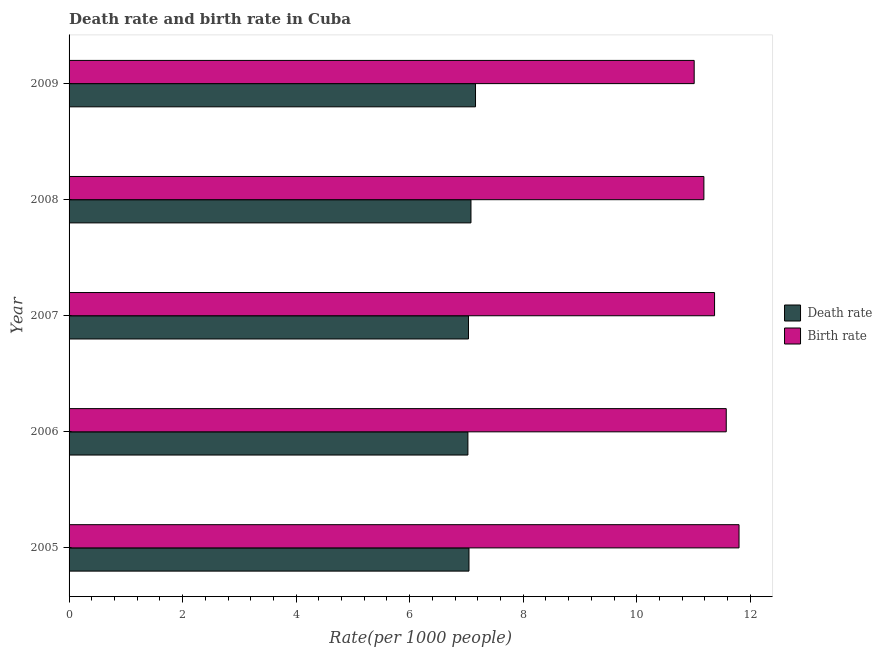How many bars are there on the 4th tick from the top?
Give a very brief answer. 2. How many bars are there on the 1st tick from the bottom?
Your response must be concise. 2. What is the label of the 3rd group of bars from the top?
Give a very brief answer. 2007. What is the birth rate in 2007?
Offer a terse response. 11.37. Across all years, what is the maximum death rate?
Your response must be concise. 7.16. Across all years, what is the minimum birth rate?
Provide a succinct answer. 11.01. What is the total birth rate in the graph?
Ensure brevity in your answer.  56.95. What is the difference between the death rate in 2005 and that in 2007?
Offer a terse response. 0.01. What is the difference between the death rate in 2006 and the birth rate in 2007?
Your answer should be very brief. -4.35. What is the average death rate per year?
Your answer should be compact. 7.07. In the year 2005, what is the difference between the death rate and birth rate?
Provide a succinct answer. -4.76. In how many years, is the death rate greater than 5.2 ?
Keep it short and to the point. 5. What is the ratio of the death rate in 2005 to that in 2008?
Your response must be concise. 0.99. Is the death rate in 2007 less than that in 2008?
Offer a terse response. Yes. Is the difference between the birth rate in 2007 and 2008 greater than the difference between the death rate in 2007 and 2008?
Your response must be concise. Yes. What is the difference between the highest and the second highest birth rate?
Offer a terse response. 0.23. What is the difference between the highest and the lowest birth rate?
Keep it short and to the point. 0.79. In how many years, is the death rate greater than the average death rate taken over all years?
Offer a terse response. 2. What does the 2nd bar from the top in 2009 represents?
Provide a succinct answer. Death rate. What does the 2nd bar from the bottom in 2009 represents?
Your answer should be very brief. Birth rate. How many bars are there?
Your answer should be compact. 10. Are all the bars in the graph horizontal?
Offer a terse response. Yes. What is the difference between two consecutive major ticks on the X-axis?
Offer a very short reply. 2. Are the values on the major ticks of X-axis written in scientific E-notation?
Give a very brief answer. No. How are the legend labels stacked?
Provide a succinct answer. Vertical. What is the title of the graph?
Give a very brief answer. Death rate and birth rate in Cuba. Does "Infant" appear as one of the legend labels in the graph?
Offer a terse response. No. What is the label or title of the X-axis?
Give a very brief answer. Rate(per 1000 people). What is the label or title of the Y-axis?
Your answer should be compact. Year. What is the Rate(per 1000 people) of Death rate in 2005?
Provide a succinct answer. 7.04. What is the Rate(per 1000 people) of Birth rate in 2005?
Offer a terse response. 11.8. What is the Rate(per 1000 people) of Death rate in 2006?
Ensure brevity in your answer.  7.03. What is the Rate(per 1000 people) of Birth rate in 2006?
Your answer should be very brief. 11.58. What is the Rate(per 1000 people) of Death rate in 2007?
Ensure brevity in your answer.  7.04. What is the Rate(per 1000 people) of Birth rate in 2007?
Make the answer very short. 11.37. What is the Rate(per 1000 people) in Death rate in 2008?
Make the answer very short. 7.08. What is the Rate(per 1000 people) of Birth rate in 2008?
Offer a terse response. 11.18. What is the Rate(per 1000 people) of Death rate in 2009?
Offer a very short reply. 7.16. What is the Rate(per 1000 people) of Birth rate in 2009?
Make the answer very short. 11.01. Across all years, what is the maximum Rate(per 1000 people) of Death rate?
Your answer should be very brief. 7.16. Across all years, what is the maximum Rate(per 1000 people) in Birth rate?
Your answer should be very brief. 11.8. Across all years, what is the minimum Rate(per 1000 people) in Death rate?
Offer a very short reply. 7.03. Across all years, what is the minimum Rate(per 1000 people) in Birth rate?
Keep it short and to the point. 11.01. What is the total Rate(per 1000 people) in Death rate in the graph?
Make the answer very short. 35.35. What is the total Rate(per 1000 people) of Birth rate in the graph?
Provide a short and direct response. 56.95. What is the difference between the Rate(per 1000 people) in Death rate in 2005 and that in 2006?
Offer a terse response. 0.02. What is the difference between the Rate(per 1000 people) of Birth rate in 2005 and that in 2006?
Make the answer very short. 0.23. What is the difference between the Rate(per 1000 people) of Death rate in 2005 and that in 2007?
Offer a terse response. 0.01. What is the difference between the Rate(per 1000 people) in Birth rate in 2005 and that in 2007?
Your answer should be compact. 0.43. What is the difference between the Rate(per 1000 people) of Death rate in 2005 and that in 2008?
Your answer should be very brief. -0.04. What is the difference between the Rate(per 1000 people) of Birth rate in 2005 and that in 2008?
Your answer should be compact. 0.62. What is the difference between the Rate(per 1000 people) of Death rate in 2005 and that in 2009?
Provide a succinct answer. -0.12. What is the difference between the Rate(per 1000 people) of Birth rate in 2005 and that in 2009?
Provide a succinct answer. 0.79. What is the difference between the Rate(per 1000 people) in Death rate in 2006 and that in 2007?
Your answer should be compact. -0.01. What is the difference between the Rate(per 1000 people) in Birth rate in 2006 and that in 2007?
Your answer should be compact. 0.21. What is the difference between the Rate(per 1000 people) of Death rate in 2006 and that in 2008?
Offer a very short reply. -0.05. What is the difference between the Rate(per 1000 people) in Birth rate in 2006 and that in 2008?
Provide a short and direct response. 0.39. What is the difference between the Rate(per 1000 people) of Death rate in 2006 and that in 2009?
Keep it short and to the point. -0.13. What is the difference between the Rate(per 1000 people) in Birth rate in 2006 and that in 2009?
Offer a terse response. 0.56. What is the difference between the Rate(per 1000 people) of Death rate in 2007 and that in 2008?
Your answer should be very brief. -0.04. What is the difference between the Rate(per 1000 people) in Birth rate in 2007 and that in 2008?
Offer a very short reply. 0.19. What is the difference between the Rate(per 1000 people) of Death rate in 2007 and that in 2009?
Ensure brevity in your answer.  -0.12. What is the difference between the Rate(per 1000 people) of Birth rate in 2007 and that in 2009?
Give a very brief answer. 0.36. What is the difference between the Rate(per 1000 people) of Death rate in 2008 and that in 2009?
Your response must be concise. -0.08. What is the difference between the Rate(per 1000 people) of Birth rate in 2008 and that in 2009?
Offer a terse response. 0.17. What is the difference between the Rate(per 1000 people) of Death rate in 2005 and the Rate(per 1000 people) of Birth rate in 2006?
Provide a succinct answer. -4.53. What is the difference between the Rate(per 1000 people) of Death rate in 2005 and the Rate(per 1000 people) of Birth rate in 2007?
Provide a succinct answer. -4.33. What is the difference between the Rate(per 1000 people) of Death rate in 2005 and the Rate(per 1000 people) of Birth rate in 2008?
Give a very brief answer. -4.14. What is the difference between the Rate(per 1000 people) of Death rate in 2005 and the Rate(per 1000 people) of Birth rate in 2009?
Provide a short and direct response. -3.97. What is the difference between the Rate(per 1000 people) of Death rate in 2006 and the Rate(per 1000 people) of Birth rate in 2007?
Make the answer very short. -4.34. What is the difference between the Rate(per 1000 people) of Death rate in 2006 and the Rate(per 1000 people) of Birth rate in 2008?
Your answer should be very brief. -4.16. What is the difference between the Rate(per 1000 people) in Death rate in 2006 and the Rate(per 1000 people) in Birth rate in 2009?
Your answer should be compact. -3.99. What is the difference between the Rate(per 1000 people) in Death rate in 2007 and the Rate(per 1000 people) in Birth rate in 2008?
Your answer should be very brief. -4.15. What is the difference between the Rate(per 1000 people) of Death rate in 2007 and the Rate(per 1000 people) of Birth rate in 2009?
Your answer should be compact. -3.98. What is the difference between the Rate(per 1000 people) in Death rate in 2008 and the Rate(per 1000 people) in Birth rate in 2009?
Ensure brevity in your answer.  -3.93. What is the average Rate(per 1000 people) in Death rate per year?
Give a very brief answer. 7.07. What is the average Rate(per 1000 people) in Birth rate per year?
Provide a succinct answer. 11.39. In the year 2005, what is the difference between the Rate(per 1000 people) in Death rate and Rate(per 1000 people) in Birth rate?
Your answer should be compact. -4.76. In the year 2006, what is the difference between the Rate(per 1000 people) in Death rate and Rate(per 1000 people) in Birth rate?
Offer a terse response. -4.55. In the year 2007, what is the difference between the Rate(per 1000 people) of Death rate and Rate(per 1000 people) of Birth rate?
Give a very brief answer. -4.33. In the year 2008, what is the difference between the Rate(per 1000 people) of Death rate and Rate(per 1000 people) of Birth rate?
Make the answer very short. -4.1. In the year 2009, what is the difference between the Rate(per 1000 people) in Death rate and Rate(per 1000 people) in Birth rate?
Provide a succinct answer. -3.85. What is the ratio of the Rate(per 1000 people) in Death rate in 2005 to that in 2006?
Your answer should be very brief. 1. What is the ratio of the Rate(per 1000 people) of Birth rate in 2005 to that in 2006?
Your answer should be very brief. 1.02. What is the ratio of the Rate(per 1000 people) of Death rate in 2005 to that in 2007?
Offer a very short reply. 1. What is the ratio of the Rate(per 1000 people) in Birth rate in 2005 to that in 2007?
Offer a very short reply. 1.04. What is the ratio of the Rate(per 1000 people) in Death rate in 2005 to that in 2008?
Make the answer very short. 1. What is the ratio of the Rate(per 1000 people) in Birth rate in 2005 to that in 2008?
Keep it short and to the point. 1.06. What is the ratio of the Rate(per 1000 people) of Death rate in 2005 to that in 2009?
Your answer should be compact. 0.98. What is the ratio of the Rate(per 1000 people) of Birth rate in 2005 to that in 2009?
Your response must be concise. 1.07. What is the ratio of the Rate(per 1000 people) of Birth rate in 2006 to that in 2007?
Your answer should be compact. 1.02. What is the ratio of the Rate(per 1000 people) of Birth rate in 2006 to that in 2008?
Your answer should be compact. 1.04. What is the ratio of the Rate(per 1000 people) of Death rate in 2006 to that in 2009?
Ensure brevity in your answer.  0.98. What is the ratio of the Rate(per 1000 people) of Birth rate in 2006 to that in 2009?
Your answer should be very brief. 1.05. What is the ratio of the Rate(per 1000 people) of Death rate in 2007 to that in 2008?
Keep it short and to the point. 0.99. What is the ratio of the Rate(per 1000 people) in Birth rate in 2007 to that in 2008?
Ensure brevity in your answer.  1.02. What is the ratio of the Rate(per 1000 people) in Death rate in 2007 to that in 2009?
Provide a short and direct response. 0.98. What is the ratio of the Rate(per 1000 people) in Birth rate in 2007 to that in 2009?
Your answer should be compact. 1.03. What is the ratio of the Rate(per 1000 people) of Death rate in 2008 to that in 2009?
Keep it short and to the point. 0.99. What is the ratio of the Rate(per 1000 people) in Birth rate in 2008 to that in 2009?
Ensure brevity in your answer.  1.02. What is the difference between the highest and the second highest Rate(per 1000 people) in Birth rate?
Provide a succinct answer. 0.23. What is the difference between the highest and the lowest Rate(per 1000 people) of Death rate?
Give a very brief answer. 0.13. What is the difference between the highest and the lowest Rate(per 1000 people) in Birth rate?
Your answer should be compact. 0.79. 